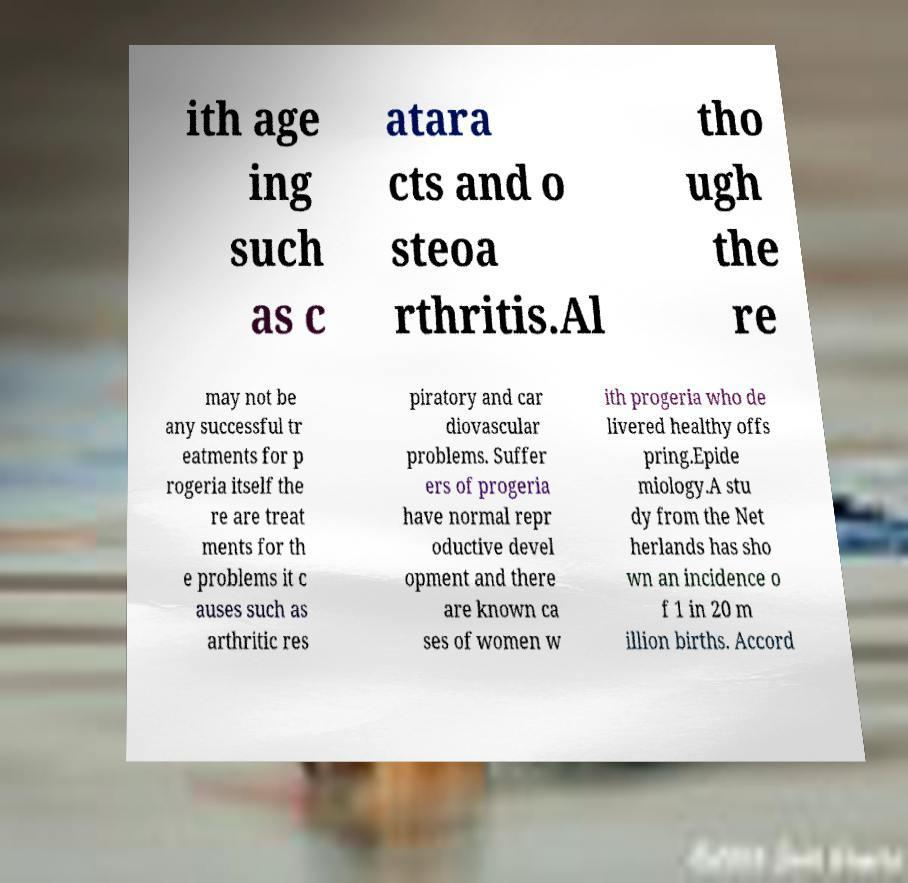There's text embedded in this image that I need extracted. Can you transcribe it verbatim? ith age ing such as c atara cts and o steoa rthritis.Al tho ugh the re may not be any successful tr eatments for p rogeria itself the re are treat ments for th e problems it c auses such as arthritic res piratory and car diovascular problems. Suffer ers of progeria have normal repr oductive devel opment and there are known ca ses of women w ith progeria who de livered healthy offs pring.Epide miology.A stu dy from the Net herlands has sho wn an incidence o f 1 in 20 m illion births. Accord 